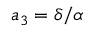<formula> <loc_0><loc_0><loc_500><loc_500>a _ { 3 } = \delta / \alpha</formula> 